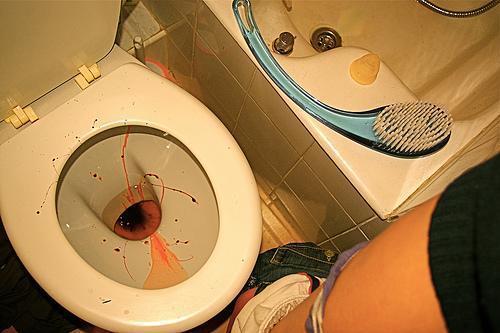How many people are there?
Give a very brief answer. 1. How many blue brushes are there?
Give a very brief answer. 1. 